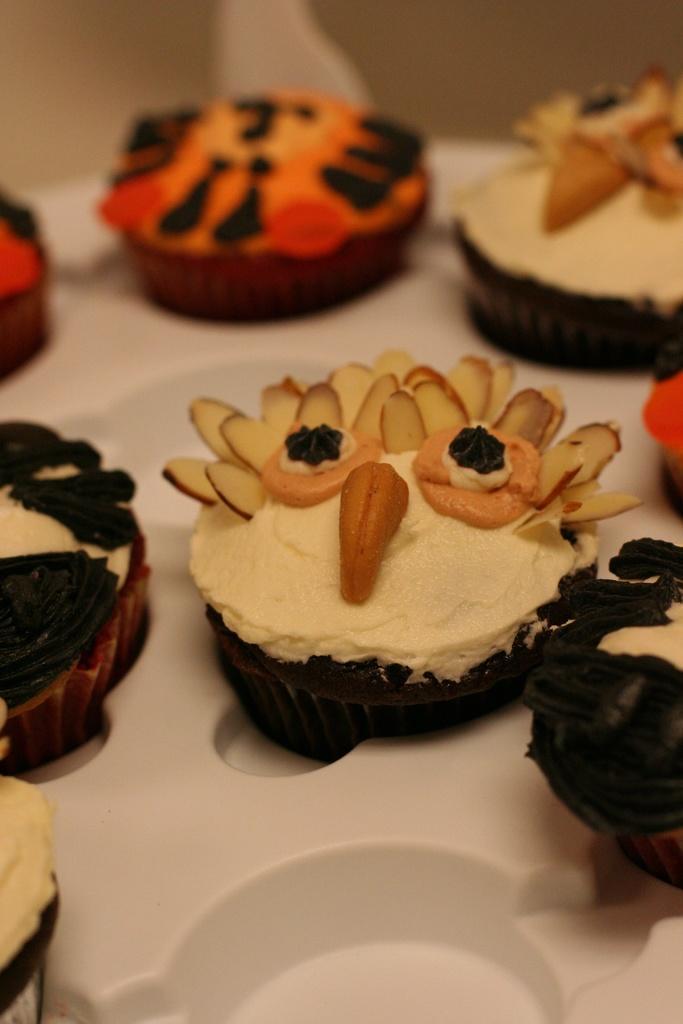Can you describe this image briefly? In this image we can see there are some cupcakes arranged on a tray. 